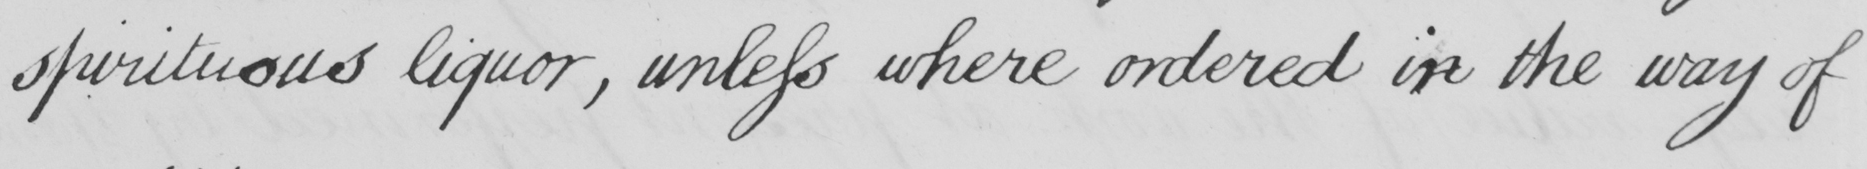Transcribe the text shown in this historical manuscript line. spirituous liquor, unless where ordered in the way of 